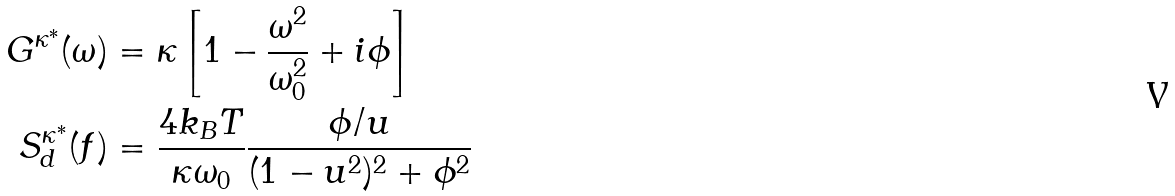<formula> <loc_0><loc_0><loc_500><loc_500>G ^ { \kappa ^ { * } } ( \omega ) & = \kappa \left [ 1 - \frac { \omega ^ { 2 } } { \omega _ { 0 } ^ { 2 } } + i \phi \right ] \\ S _ { d } ^ { \kappa ^ { * } } ( f ) & = \frac { 4 k _ { B } T } { \kappa \omega _ { 0 } } \frac { \phi / u } { ( 1 - u ^ { 2 } ) ^ { 2 } + \phi ^ { 2 } }</formula> 